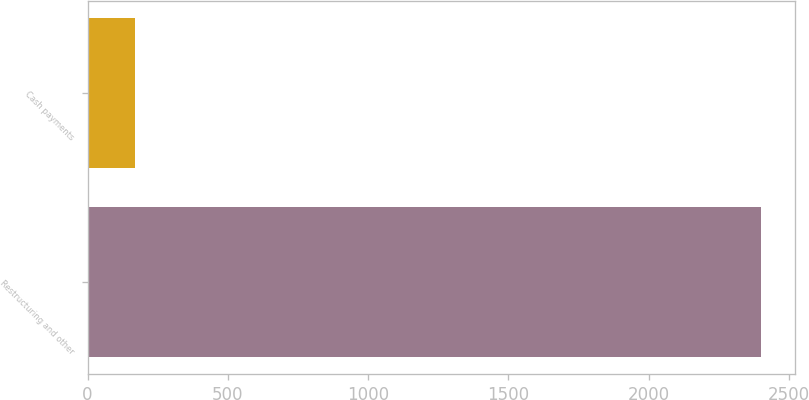Convert chart to OTSL. <chart><loc_0><loc_0><loc_500><loc_500><bar_chart><fcel>Restructuring and other<fcel>Cash payments<nl><fcel>2401<fcel>169<nl></chart> 